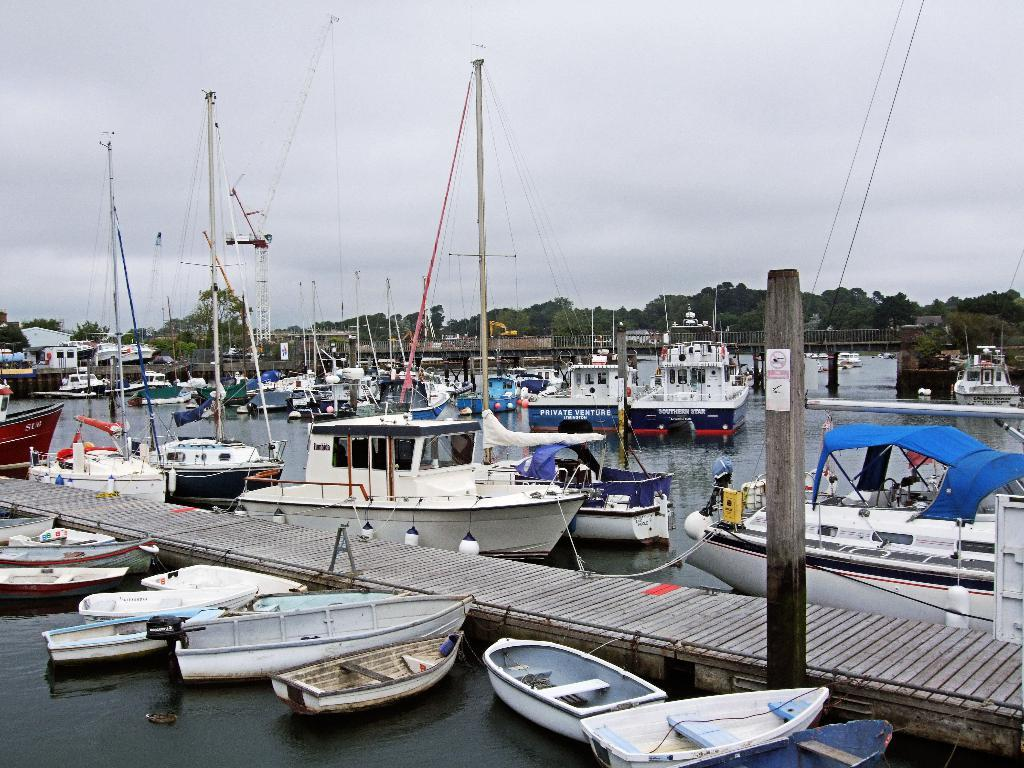What is floating on the surface of the water in the image? There are boats on the surface of the water in the image. What can be seen on the ground in the image? There is a path visible in the image. What type of structures are present in the image? Wooden pillars are present in the image. What is visible above the ground in the image? The sky is visible in the image. What type of lead can be seen in the image? There is no lead present in the image. How many quarters are visible in the image? There are no quarters visible in the image. 